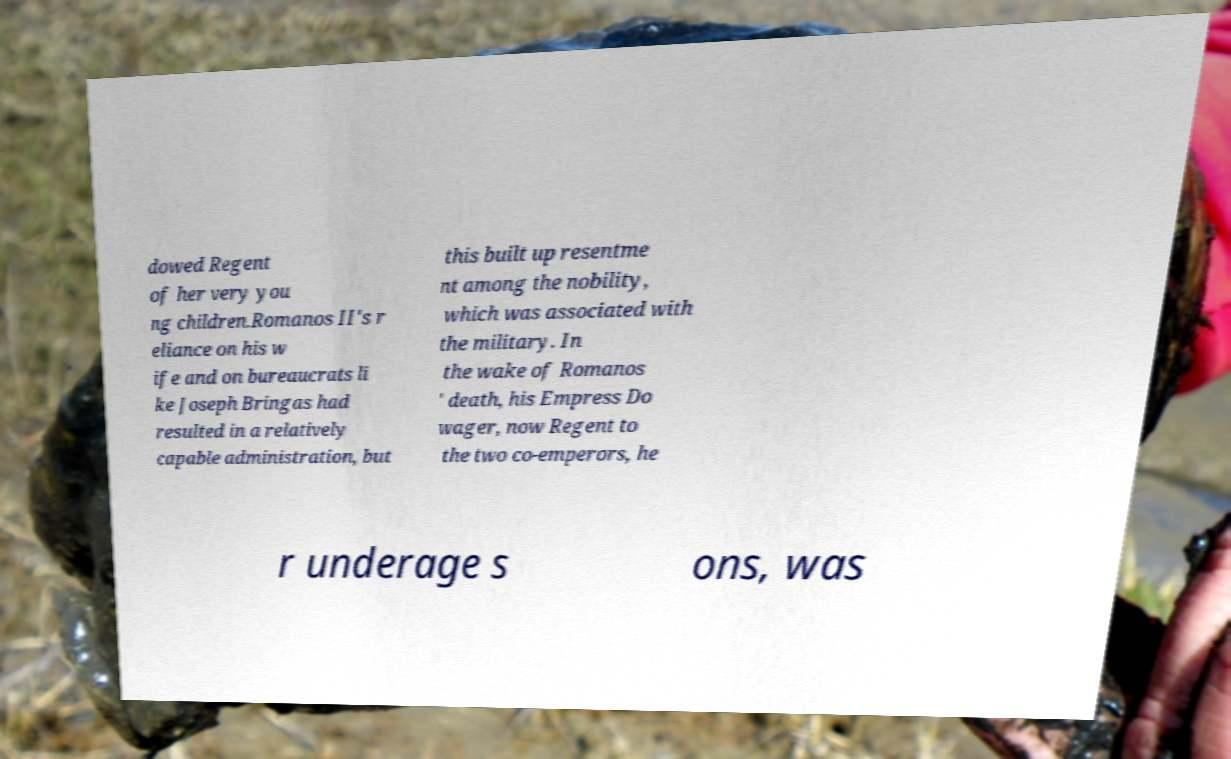Please identify and transcribe the text found in this image. dowed Regent of her very you ng children.Romanos II's r eliance on his w ife and on bureaucrats li ke Joseph Bringas had resulted in a relatively capable administration, but this built up resentme nt among the nobility, which was associated with the military. In the wake of Romanos ' death, his Empress Do wager, now Regent to the two co-emperors, he r underage s ons, was 